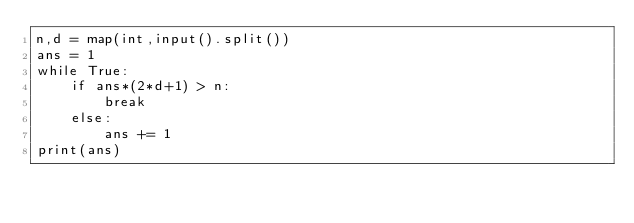<code> <loc_0><loc_0><loc_500><loc_500><_Python_>n,d = map(int,input().split())
ans = 1
while True:
    if ans*(2*d+1) > n:
        break
    else:
        ans += 1
print(ans)</code> 